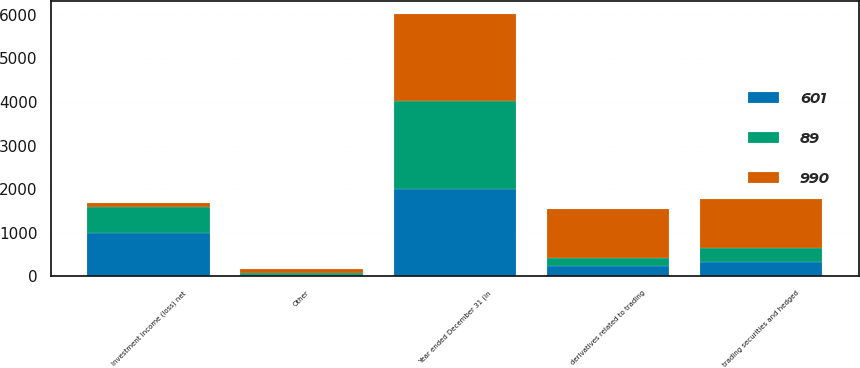Convert chart to OTSL. <chart><loc_0><loc_0><loc_500><loc_500><stacked_bar_chart><ecel><fcel>Year ended December 31 (in<fcel>trading securities and hedged<fcel>derivatives related to trading<fcel>Other<fcel>Investment income (loss) net<nl><fcel>990<fcel>2008<fcel>1117<fcel>1120<fcel>100<fcel>89<nl><fcel>89<fcel>2007<fcel>315<fcel>188<fcel>32<fcel>601<nl><fcel>601<fcel>2006<fcel>339<fcel>238<fcel>34<fcel>990<nl></chart> 